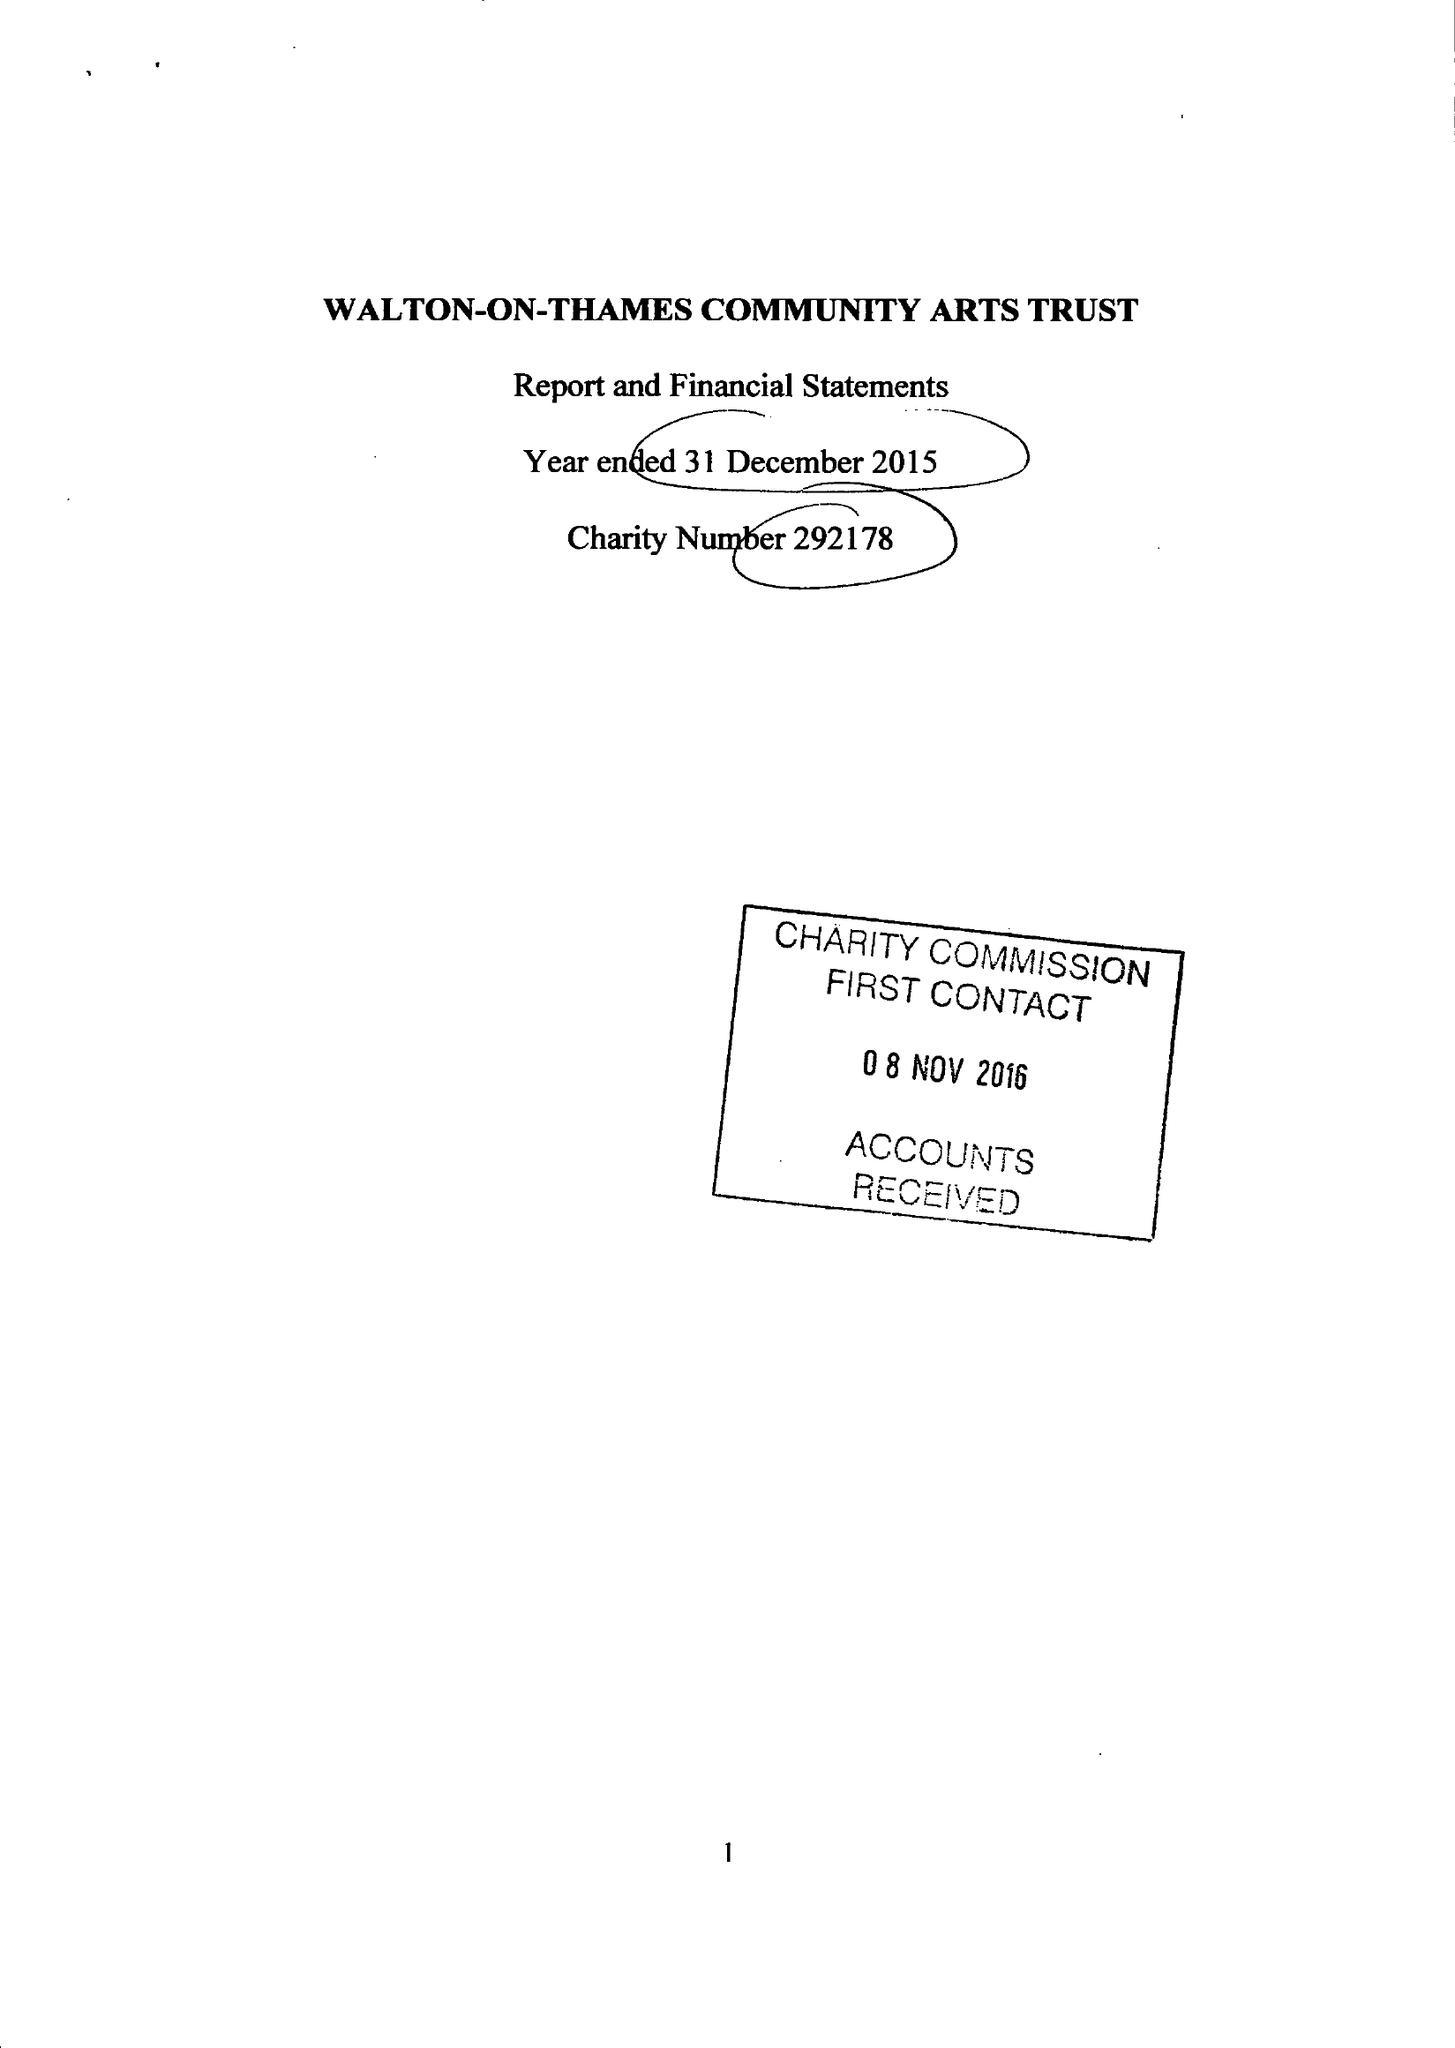What is the value for the charity_name?
Answer the question using a single word or phrase. Walton-On-Thames Community Arts Trust 